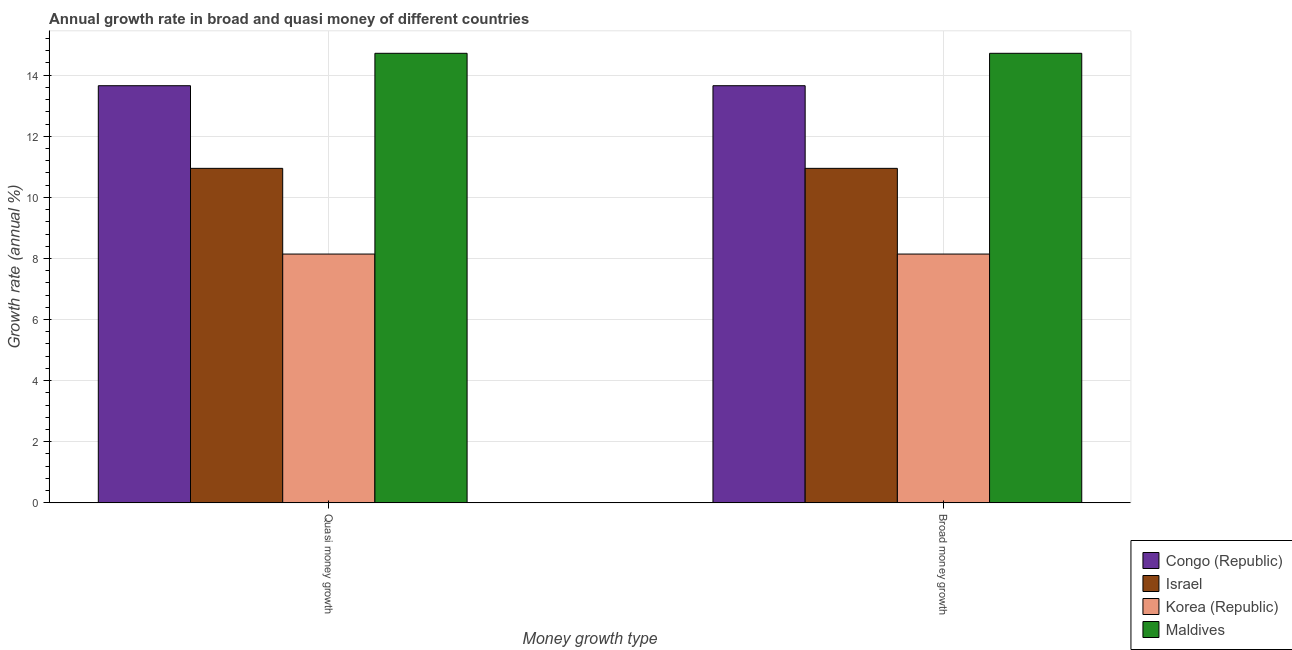How many different coloured bars are there?
Your answer should be compact. 4. Are the number of bars per tick equal to the number of legend labels?
Give a very brief answer. Yes. Are the number of bars on each tick of the X-axis equal?
Your response must be concise. Yes. What is the label of the 1st group of bars from the left?
Provide a short and direct response. Quasi money growth. What is the annual growth rate in quasi money in Israel?
Keep it short and to the point. 10.95. Across all countries, what is the maximum annual growth rate in quasi money?
Keep it short and to the point. 14.72. Across all countries, what is the minimum annual growth rate in quasi money?
Your answer should be very brief. 8.14. In which country was the annual growth rate in quasi money maximum?
Your response must be concise. Maldives. In which country was the annual growth rate in quasi money minimum?
Provide a short and direct response. Korea (Republic). What is the total annual growth rate in quasi money in the graph?
Your answer should be compact. 47.47. What is the difference between the annual growth rate in quasi money in Israel and that in Congo (Republic)?
Make the answer very short. -2.71. What is the difference between the annual growth rate in quasi money in Korea (Republic) and the annual growth rate in broad money in Maldives?
Give a very brief answer. -6.57. What is the average annual growth rate in broad money per country?
Offer a very short reply. 11.87. What is the difference between the annual growth rate in broad money and annual growth rate in quasi money in Congo (Republic)?
Make the answer very short. 0. In how many countries, is the annual growth rate in broad money greater than 14.8 %?
Provide a succinct answer. 0. What is the ratio of the annual growth rate in broad money in Congo (Republic) to that in Israel?
Provide a short and direct response. 1.25. What does the 1st bar from the left in Quasi money growth represents?
Provide a short and direct response. Congo (Republic). What does the 4th bar from the right in Broad money growth represents?
Ensure brevity in your answer.  Congo (Republic). How many bars are there?
Your response must be concise. 8. Are all the bars in the graph horizontal?
Your answer should be very brief. No. How many countries are there in the graph?
Provide a short and direct response. 4. What is the difference between two consecutive major ticks on the Y-axis?
Your answer should be compact. 2. Are the values on the major ticks of Y-axis written in scientific E-notation?
Your answer should be compact. No. Where does the legend appear in the graph?
Keep it short and to the point. Bottom right. How many legend labels are there?
Make the answer very short. 4. How are the legend labels stacked?
Your answer should be very brief. Vertical. What is the title of the graph?
Your response must be concise. Annual growth rate in broad and quasi money of different countries. What is the label or title of the X-axis?
Your response must be concise. Money growth type. What is the label or title of the Y-axis?
Make the answer very short. Growth rate (annual %). What is the Growth rate (annual %) in Congo (Republic) in Quasi money growth?
Make the answer very short. 13.66. What is the Growth rate (annual %) in Israel in Quasi money growth?
Offer a terse response. 10.95. What is the Growth rate (annual %) in Korea (Republic) in Quasi money growth?
Keep it short and to the point. 8.14. What is the Growth rate (annual %) of Maldives in Quasi money growth?
Ensure brevity in your answer.  14.72. What is the Growth rate (annual %) of Congo (Republic) in Broad money growth?
Give a very brief answer. 13.66. What is the Growth rate (annual %) in Israel in Broad money growth?
Your answer should be compact. 10.95. What is the Growth rate (annual %) of Korea (Republic) in Broad money growth?
Offer a very short reply. 8.14. What is the Growth rate (annual %) in Maldives in Broad money growth?
Offer a very short reply. 14.72. Across all Money growth type, what is the maximum Growth rate (annual %) in Congo (Republic)?
Provide a short and direct response. 13.66. Across all Money growth type, what is the maximum Growth rate (annual %) in Israel?
Your response must be concise. 10.95. Across all Money growth type, what is the maximum Growth rate (annual %) of Korea (Republic)?
Your answer should be very brief. 8.14. Across all Money growth type, what is the maximum Growth rate (annual %) in Maldives?
Your answer should be very brief. 14.72. Across all Money growth type, what is the minimum Growth rate (annual %) in Congo (Republic)?
Offer a very short reply. 13.66. Across all Money growth type, what is the minimum Growth rate (annual %) in Israel?
Offer a very short reply. 10.95. Across all Money growth type, what is the minimum Growth rate (annual %) in Korea (Republic)?
Ensure brevity in your answer.  8.14. Across all Money growth type, what is the minimum Growth rate (annual %) in Maldives?
Offer a terse response. 14.72. What is the total Growth rate (annual %) of Congo (Republic) in the graph?
Your answer should be compact. 27.31. What is the total Growth rate (annual %) of Israel in the graph?
Your answer should be compact. 21.9. What is the total Growth rate (annual %) in Korea (Republic) in the graph?
Ensure brevity in your answer.  16.29. What is the total Growth rate (annual %) of Maldives in the graph?
Your answer should be compact. 29.43. What is the difference between the Growth rate (annual %) of Israel in Quasi money growth and that in Broad money growth?
Your answer should be compact. 0. What is the difference between the Growth rate (annual %) in Korea (Republic) in Quasi money growth and that in Broad money growth?
Ensure brevity in your answer.  0. What is the difference between the Growth rate (annual %) in Maldives in Quasi money growth and that in Broad money growth?
Offer a very short reply. 0. What is the difference between the Growth rate (annual %) of Congo (Republic) in Quasi money growth and the Growth rate (annual %) of Israel in Broad money growth?
Your answer should be compact. 2.71. What is the difference between the Growth rate (annual %) in Congo (Republic) in Quasi money growth and the Growth rate (annual %) in Korea (Republic) in Broad money growth?
Offer a very short reply. 5.51. What is the difference between the Growth rate (annual %) in Congo (Republic) in Quasi money growth and the Growth rate (annual %) in Maldives in Broad money growth?
Provide a succinct answer. -1.06. What is the difference between the Growth rate (annual %) in Israel in Quasi money growth and the Growth rate (annual %) in Korea (Republic) in Broad money growth?
Your answer should be very brief. 2.81. What is the difference between the Growth rate (annual %) of Israel in Quasi money growth and the Growth rate (annual %) of Maldives in Broad money growth?
Offer a very short reply. -3.77. What is the difference between the Growth rate (annual %) of Korea (Republic) in Quasi money growth and the Growth rate (annual %) of Maldives in Broad money growth?
Provide a succinct answer. -6.57. What is the average Growth rate (annual %) in Congo (Republic) per Money growth type?
Your answer should be very brief. 13.66. What is the average Growth rate (annual %) in Israel per Money growth type?
Ensure brevity in your answer.  10.95. What is the average Growth rate (annual %) in Korea (Republic) per Money growth type?
Your answer should be very brief. 8.14. What is the average Growth rate (annual %) in Maldives per Money growth type?
Your answer should be very brief. 14.72. What is the difference between the Growth rate (annual %) of Congo (Republic) and Growth rate (annual %) of Israel in Quasi money growth?
Your response must be concise. 2.71. What is the difference between the Growth rate (annual %) of Congo (Republic) and Growth rate (annual %) of Korea (Republic) in Quasi money growth?
Offer a terse response. 5.51. What is the difference between the Growth rate (annual %) in Congo (Republic) and Growth rate (annual %) in Maldives in Quasi money growth?
Your response must be concise. -1.06. What is the difference between the Growth rate (annual %) in Israel and Growth rate (annual %) in Korea (Republic) in Quasi money growth?
Offer a terse response. 2.81. What is the difference between the Growth rate (annual %) of Israel and Growth rate (annual %) of Maldives in Quasi money growth?
Offer a very short reply. -3.77. What is the difference between the Growth rate (annual %) of Korea (Republic) and Growth rate (annual %) of Maldives in Quasi money growth?
Keep it short and to the point. -6.57. What is the difference between the Growth rate (annual %) in Congo (Republic) and Growth rate (annual %) in Israel in Broad money growth?
Your answer should be compact. 2.71. What is the difference between the Growth rate (annual %) of Congo (Republic) and Growth rate (annual %) of Korea (Republic) in Broad money growth?
Ensure brevity in your answer.  5.51. What is the difference between the Growth rate (annual %) of Congo (Republic) and Growth rate (annual %) of Maldives in Broad money growth?
Give a very brief answer. -1.06. What is the difference between the Growth rate (annual %) of Israel and Growth rate (annual %) of Korea (Republic) in Broad money growth?
Make the answer very short. 2.81. What is the difference between the Growth rate (annual %) in Israel and Growth rate (annual %) in Maldives in Broad money growth?
Give a very brief answer. -3.77. What is the difference between the Growth rate (annual %) of Korea (Republic) and Growth rate (annual %) of Maldives in Broad money growth?
Offer a very short reply. -6.57. What is the ratio of the Growth rate (annual %) in Congo (Republic) in Quasi money growth to that in Broad money growth?
Provide a short and direct response. 1. What is the ratio of the Growth rate (annual %) in Korea (Republic) in Quasi money growth to that in Broad money growth?
Provide a succinct answer. 1. 